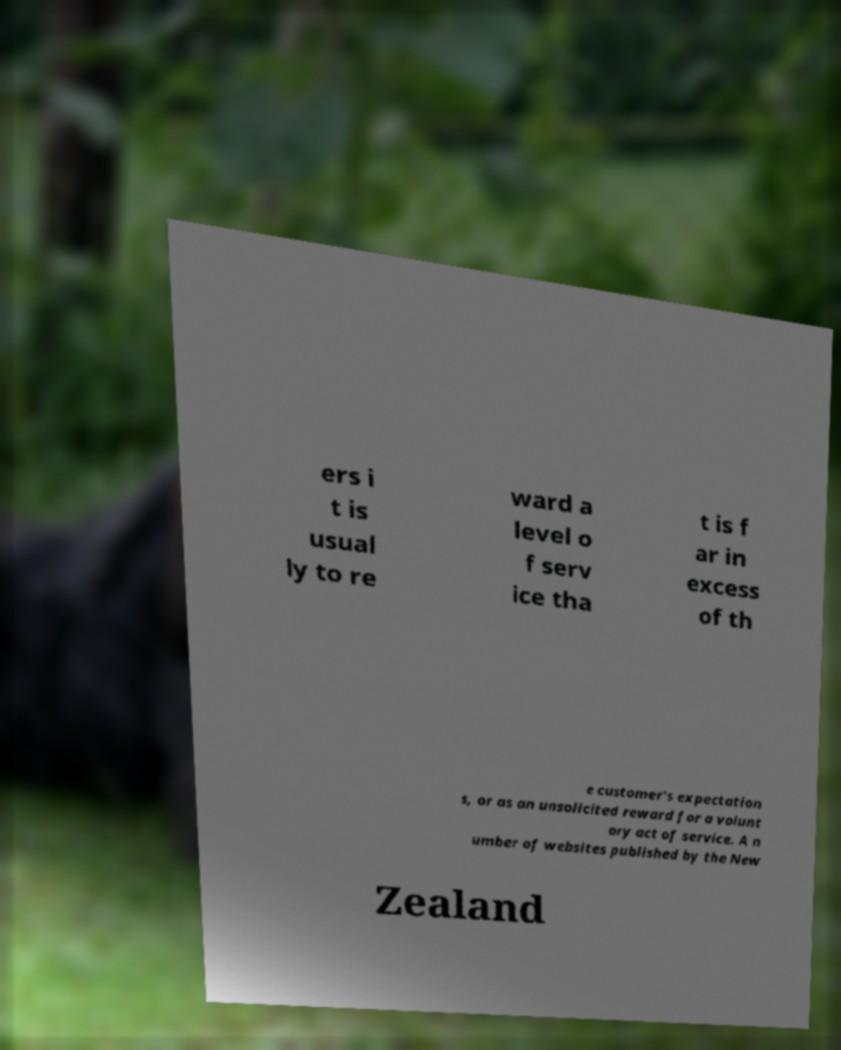What messages or text are displayed in this image? I need them in a readable, typed format. ers i t is usual ly to re ward a level o f serv ice tha t is f ar in excess of th e customer's expectation s, or as an unsolicited reward for a volunt ary act of service. A n umber of websites published by the New Zealand 